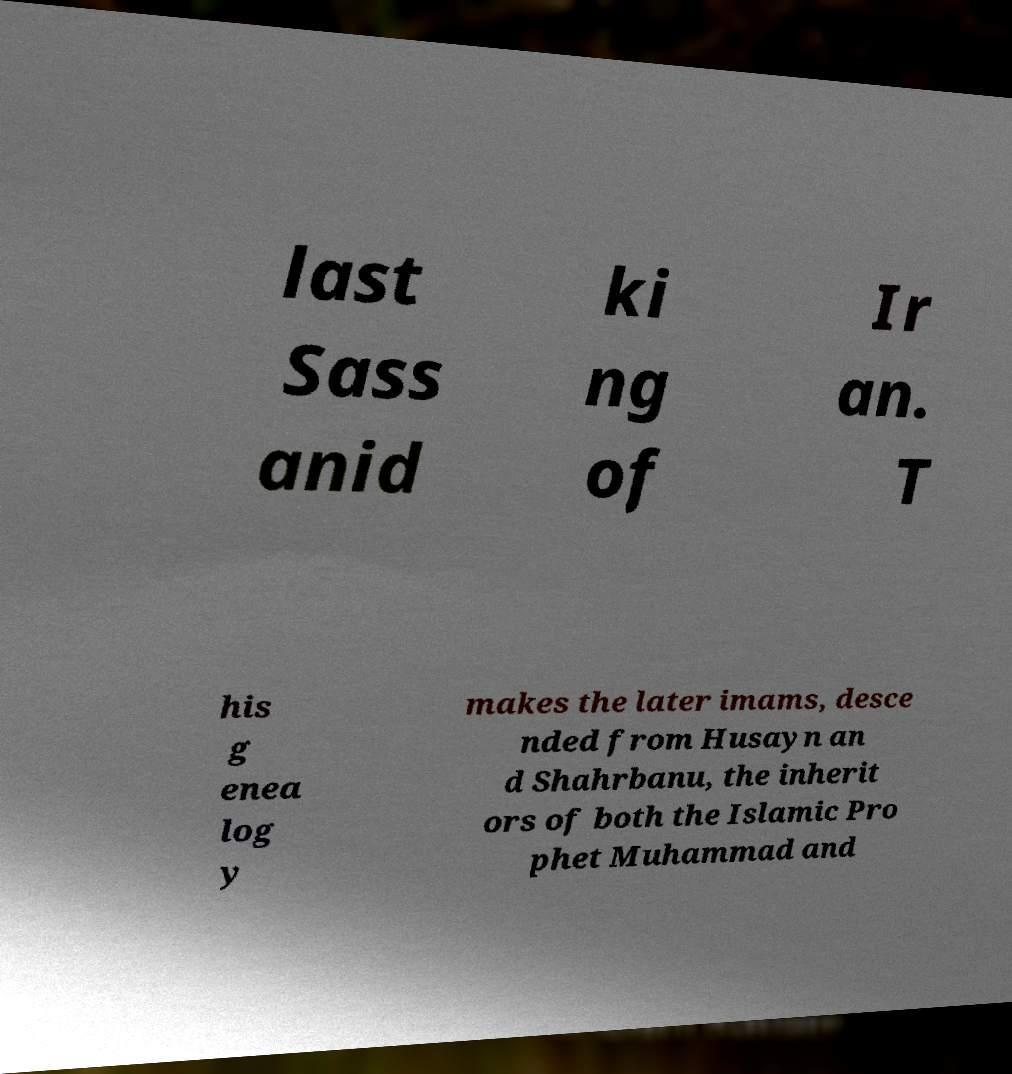Can you accurately transcribe the text from the provided image for me? last Sass anid ki ng of Ir an. T his g enea log y makes the later imams, desce nded from Husayn an d Shahrbanu, the inherit ors of both the Islamic Pro phet Muhammad and 